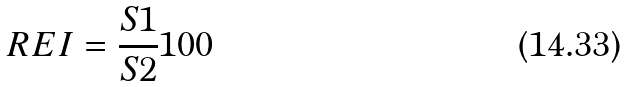<formula> <loc_0><loc_0><loc_500><loc_500>R E I = \frac { S 1 } { S 2 } 1 0 0</formula> 